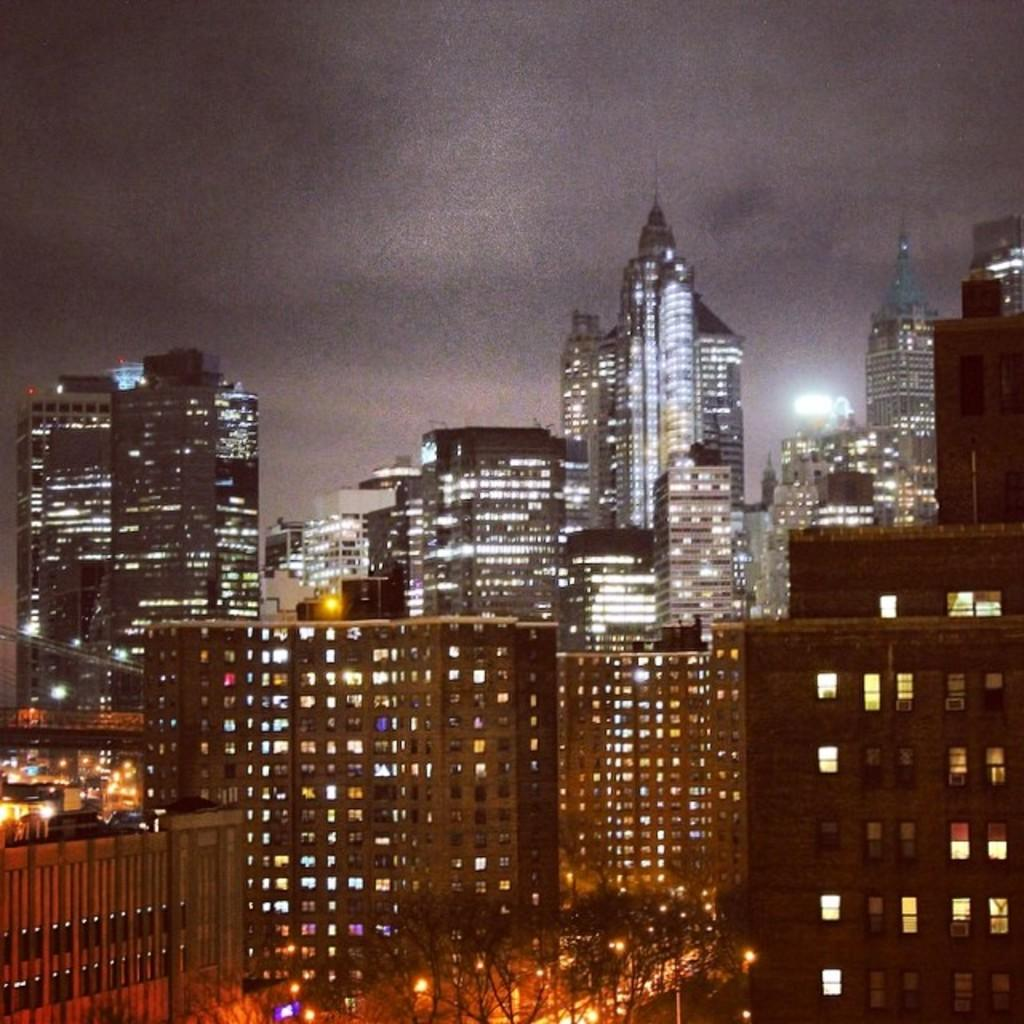What type of natural elements can be seen in the image? There are trees in the image. What type of man-made structures are present in the image? There are buildings in the image. What type of illumination is visible in the image? There are lights in the image. What type of parcel is being delivered by the plane in the image? There is no plane or parcel present in the image. What is the middle of the image showing? The provided facts do not mention a specific middle point in the image, so it cannot be determined from the information given. 